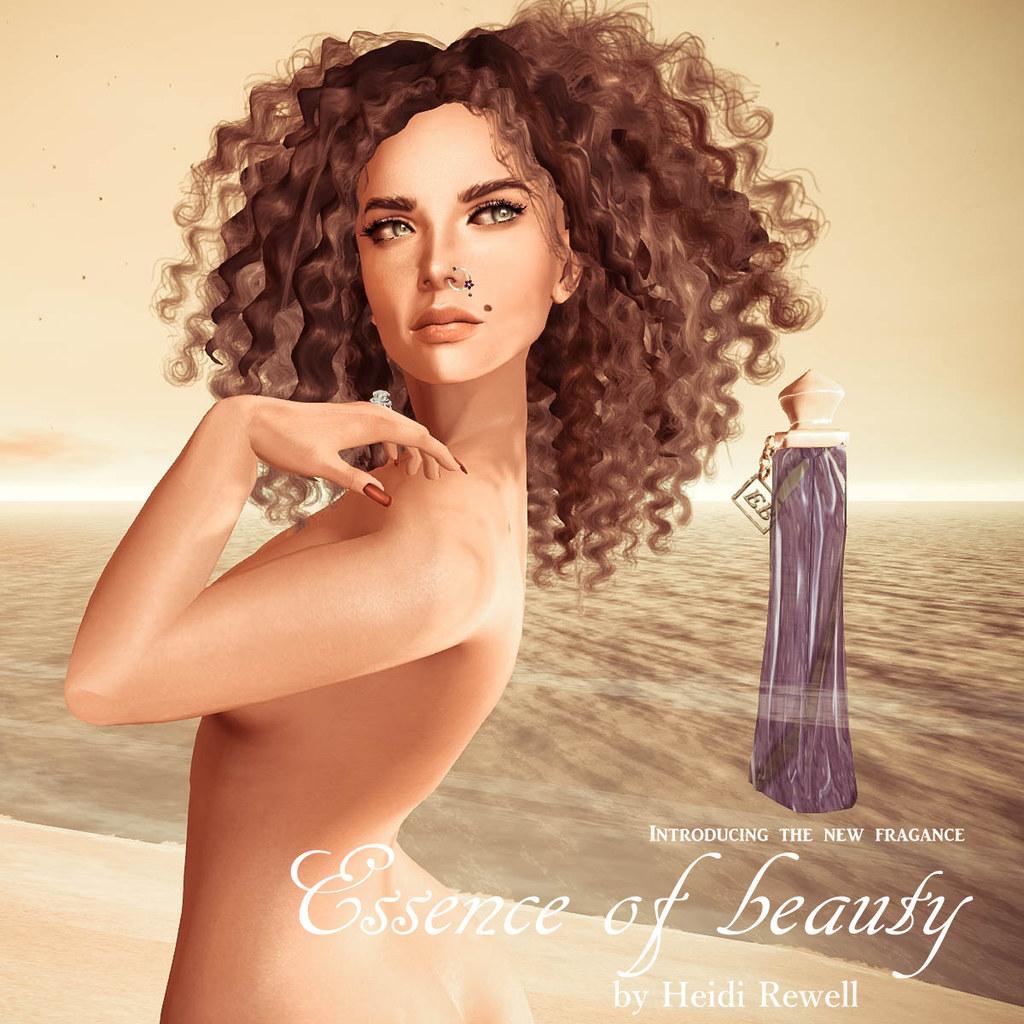Who is the creator is the new fragrance?
Provide a succinct answer. Heidi rewell. What is the name of the fragrance?
Keep it short and to the point. Essence of beauty. 